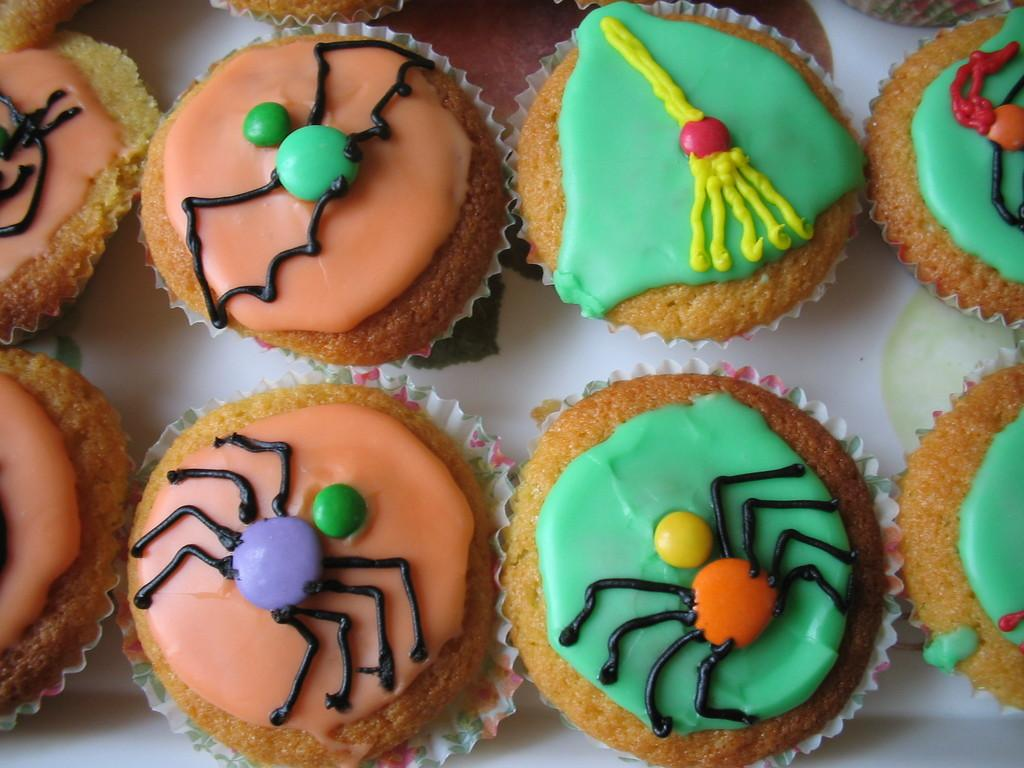What type of food can be seen on the table in the image? There are desserts on the table in the image. What type of ring can be seen on the dessert in the image? There is no ring present on the dessert in the image. What type of lipstick is being used by the dessert in the image? There are no lips or lipstick in the image, as it features desserts on a table. 